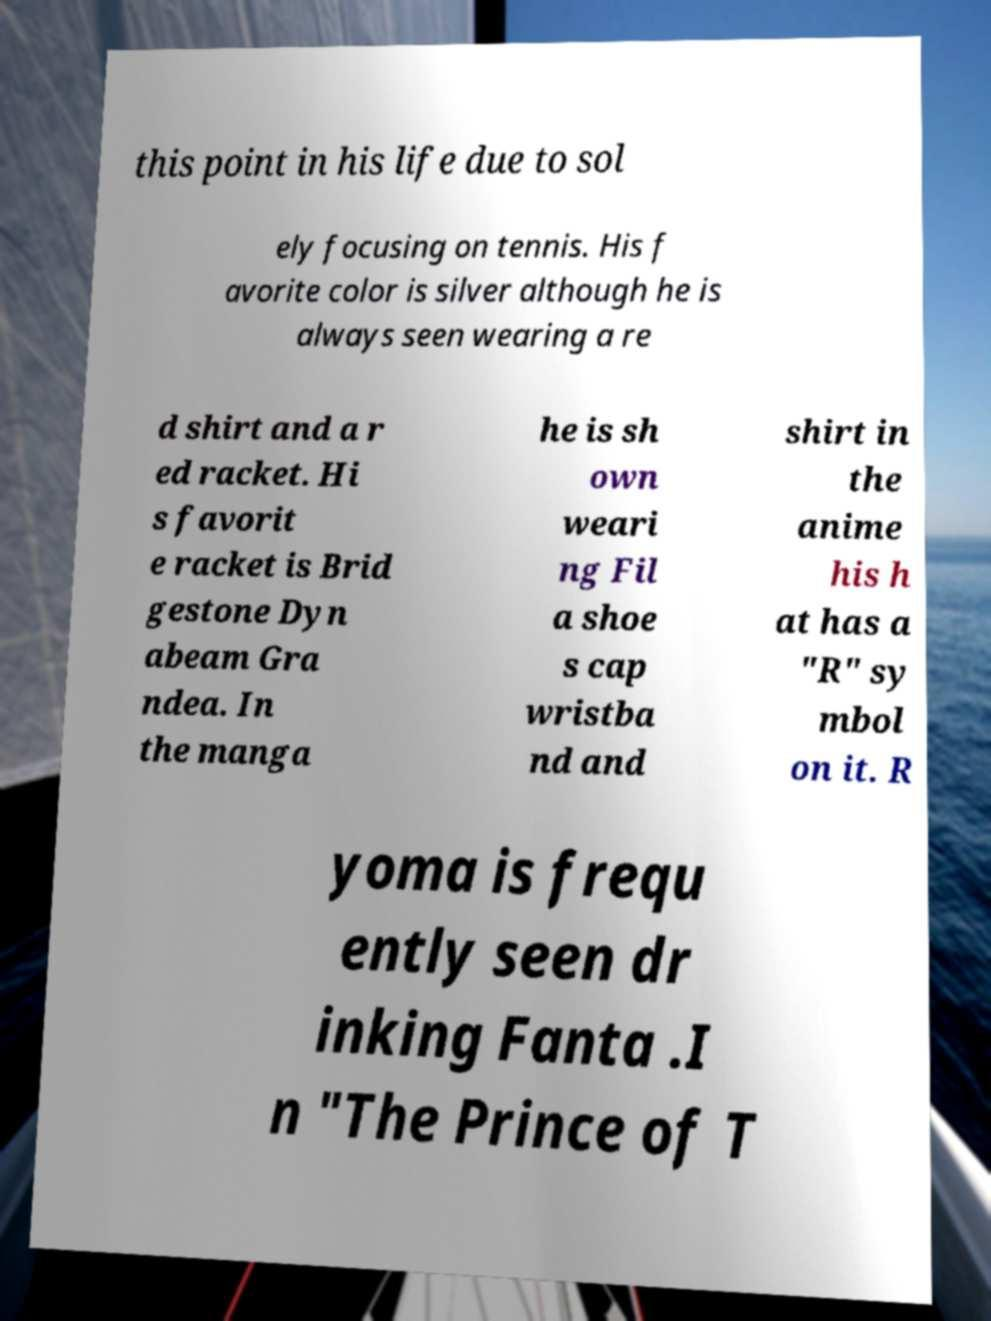Can you read and provide the text displayed in the image?This photo seems to have some interesting text. Can you extract and type it out for me? this point in his life due to sol ely focusing on tennis. His f avorite color is silver although he is always seen wearing a re d shirt and a r ed racket. Hi s favorit e racket is Brid gestone Dyn abeam Gra ndea. In the manga he is sh own weari ng Fil a shoe s cap wristba nd and shirt in the anime his h at has a "R" sy mbol on it. R yoma is frequ ently seen dr inking Fanta .I n "The Prince of T 